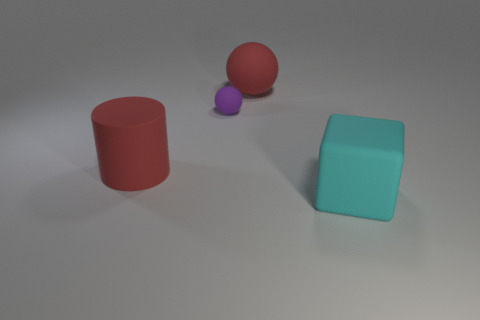Add 2 small purple objects. How many objects exist? 6 Subtract all cylinders. How many objects are left? 3 Subtract all purple matte objects. Subtract all large red spheres. How many objects are left? 2 Add 3 large cyan rubber blocks. How many large cyan rubber blocks are left? 4 Add 4 matte cubes. How many matte cubes exist? 5 Subtract 0 green spheres. How many objects are left? 4 